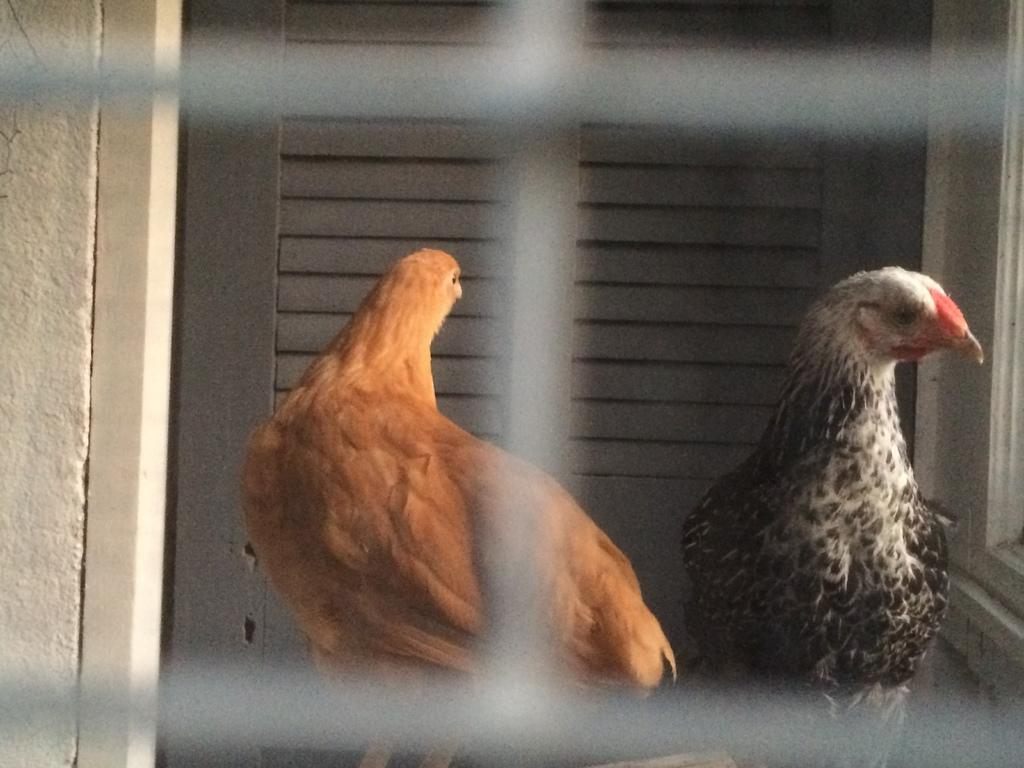How many hens are present in the image? There are two hens in the image. Where are the hens located? The hens are in a cage. What can be seen in the background of the image? There is a door in the background of the image. What is on the left side of the image? There is a well on the left side of the image. What type of cherry is being held by the hen's face in the image? There are no cherries or faces present in the image; it features two hens in a cage, a door in the background, and a well on the left side. 